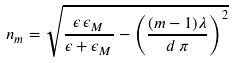Convert formula to latex. <formula><loc_0><loc_0><loc_500><loc_500>n _ { m } = \sqrt { \frac { \epsilon \, \epsilon _ { M } } { \epsilon + \epsilon _ { M } } - \left ( \frac { ( m - 1 ) \lambda } { d \, \pi } \right ) ^ { 2 } }</formula> 